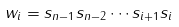<formula> <loc_0><loc_0><loc_500><loc_500>w _ { i } = s _ { n - 1 } s _ { n - 2 } \cdots s _ { i + 1 } s _ { i }</formula> 